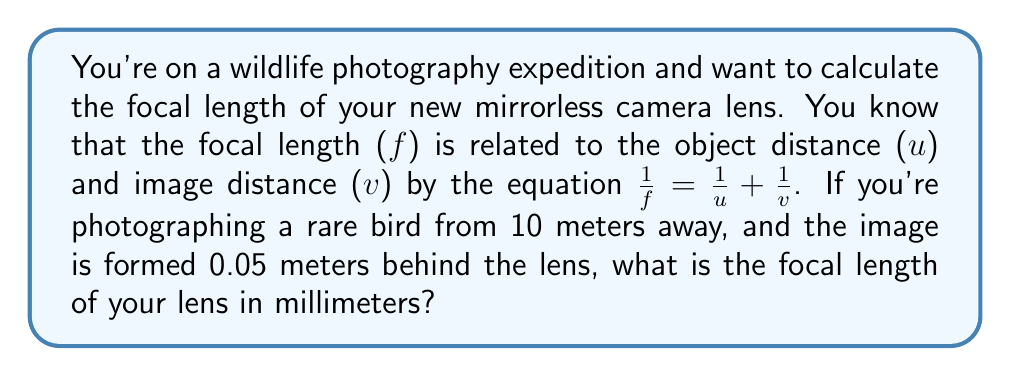What is the answer to this math problem? Let's solve this problem step by step:

1. We are given the following information:
   - Object distance (u) = 10 meters
   - Image distance (v) = 0.05 meters
   - The equation: $\frac{1}{f} = \frac{1}{u} + \frac{1}{v}$

2. Let's substitute the known values into the equation:
   $$\frac{1}{f} = \frac{1}{10} + \frac{1}{0.05}$$

3. Now, let's solve for f:
   $$\frac{1}{f} = 0.1 + 20 = 20.1$$

4. To isolate f, we take the reciprocal of both sides:
   $$f = \frac{1}{20.1}$$

5. Calculate the value of f:
   $$f \approx 0.04975124378 \text{ meters}$$

6. Convert the focal length to millimeters:
   $$f \approx 0.04975124378 \times 1000 = 49.75124378 \text{ mm}$$

7. Round to two decimal places for practical use:
   $$f \approx 49.75 \text{ mm}$$
Answer: 49.75 mm 